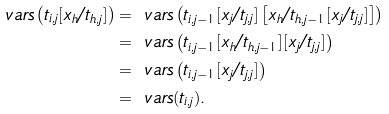Convert formula to latex. <formula><loc_0><loc_0><loc_500><loc_500>\ v a r s \left ( t _ { i , j } [ x _ { h } / t _ { h , j } ] \right ) & = \ v a r s \left ( t _ { i , j - 1 } [ x _ { j } / t _ { j , j } ] \left [ x _ { h } / t _ { h , j - 1 } [ x _ { j } / t _ { j , j } ] \right ] \right ) \\ & = \ v a r s \left ( t _ { i , j - 1 } [ x _ { h } / t _ { h , j - 1 } ] [ x _ { j } / t _ { j , j } ] \right ) \\ & = \ v a r s \left ( t _ { i , j - 1 } [ x _ { j } / t _ { j , j } ] \right ) \\ & = \ v a r s ( t _ { i , j } ) .</formula> 